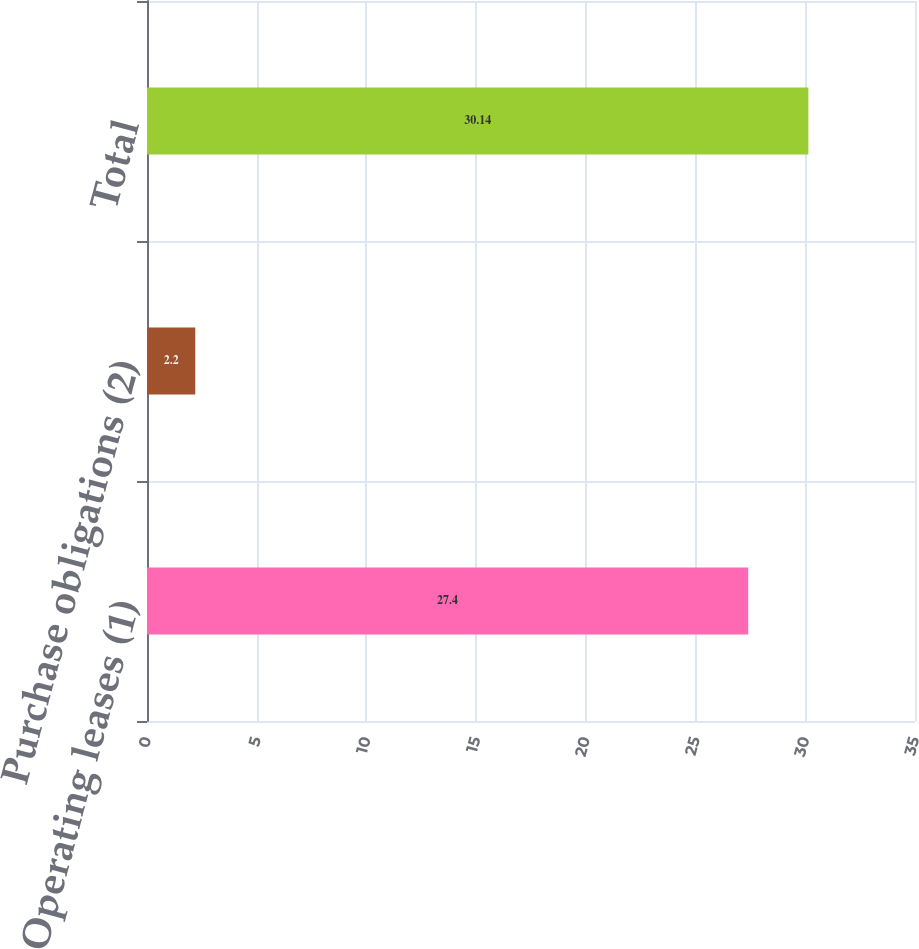Convert chart to OTSL. <chart><loc_0><loc_0><loc_500><loc_500><bar_chart><fcel>Operating leases (1)<fcel>Purchase obligations (2)<fcel>Total<nl><fcel>27.4<fcel>2.2<fcel>30.14<nl></chart> 